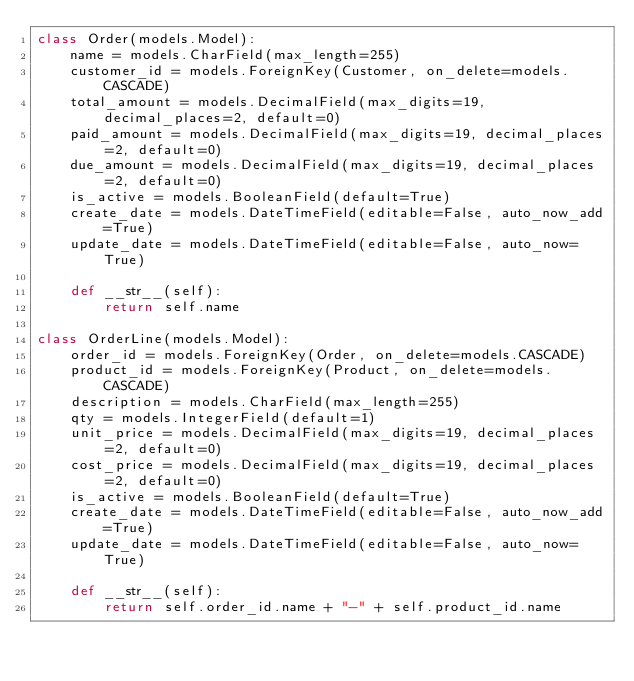Convert code to text. <code><loc_0><loc_0><loc_500><loc_500><_Python_>class Order(models.Model):
    name = models.CharField(max_length=255)
    customer_id = models.ForeignKey(Customer, on_delete=models.CASCADE)
    total_amount = models.DecimalField(max_digits=19, decimal_places=2, default=0)
    paid_amount = models.DecimalField(max_digits=19, decimal_places=2, default=0)
    due_amount = models.DecimalField(max_digits=19, decimal_places=2, default=0)
    is_active = models.BooleanField(default=True)
    create_date = models.DateTimeField(editable=False, auto_now_add=True)
    update_date = models.DateTimeField(editable=False, auto_now=True)

    def __str__(self):
        return self.name

class OrderLine(models.Model):
    order_id = models.ForeignKey(Order, on_delete=models.CASCADE)
    product_id = models.ForeignKey(Product, on_delete=models.CASCADE)
    description = models.CharField(max_length=255)
    qty = models.IntegerField(default=1)
    unit_price = models.DecimalField(max_digits=19, decimal_places=2, default=0)
    cost_price = models.DecimalField(max_digits=19, decimal_places=2, default=0)
    is_active = models.BooleanField(default=True)
    create_date = models.DateTimeField(editable=False, auto_now_add=True)
    update_date = models.DateTimeField(editable=False, auto_now=True)

    def __str__(self):
        return self.order_id.name + "-" + self.product_id.name</code> 